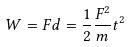<formula> <loc_0><loc_0><loc_500><loc_500>W = F d = \frac { 1 } { 2 } \frac { F ^ { 2 } } { m } t ^ { 2 }</formula> 